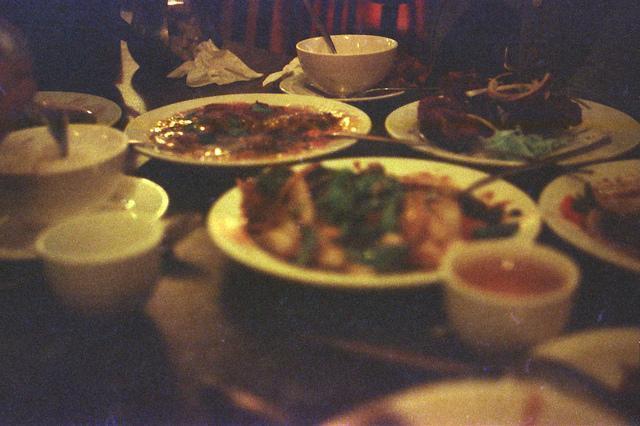How many cups can you see?
Give a very brief answer. 2. How many bowls are visible?
Give a very brief answer. 4. How many people are in this photo?
Give a very brief answer. 0. 